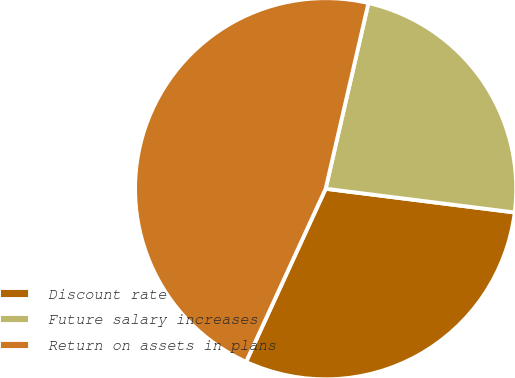Convert chart. <chart><loc_0><loc_0><loc_500><loc_500><pie_chart><fcel>Discount rate<fcel>Future salary increases<fcel>Return on assets in plans<nl><fcel>29.87%<fcel>23.38%<fcel>46.75%<nl></chart> 